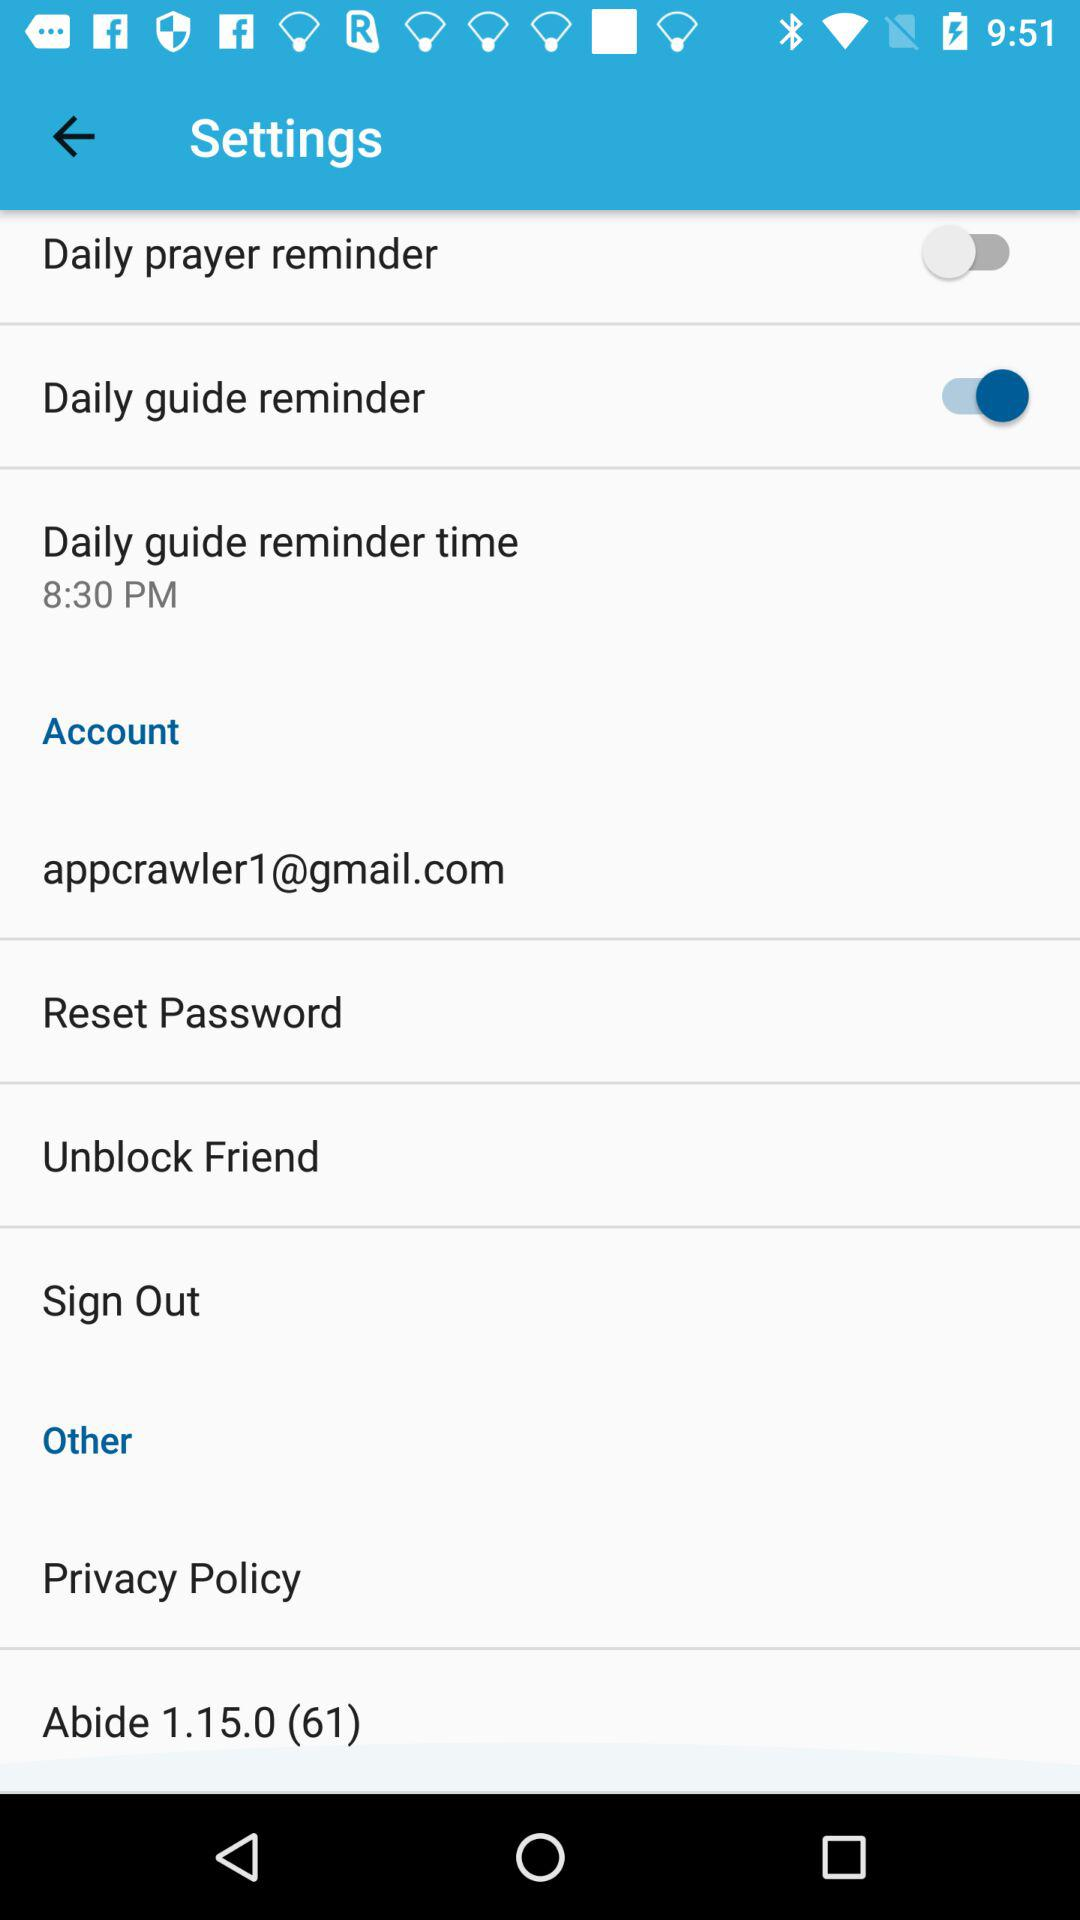What is the daily guide reminder time? The daily guide reminder time is 8:30 PM. 